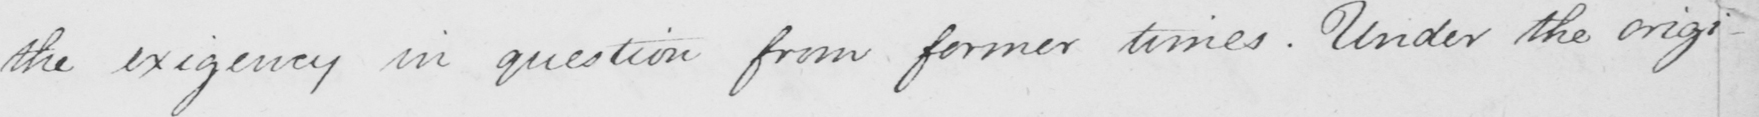Can you tell me what this handwritten text says? the exigency in question from former times . Under the origi- 